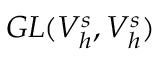Convert formula to latex. <formula><loc_0><loc_0><loc_500><loc_500>G L ( V _ { h } ^ { s } , V _ { h } ^ { s } )</formula> 